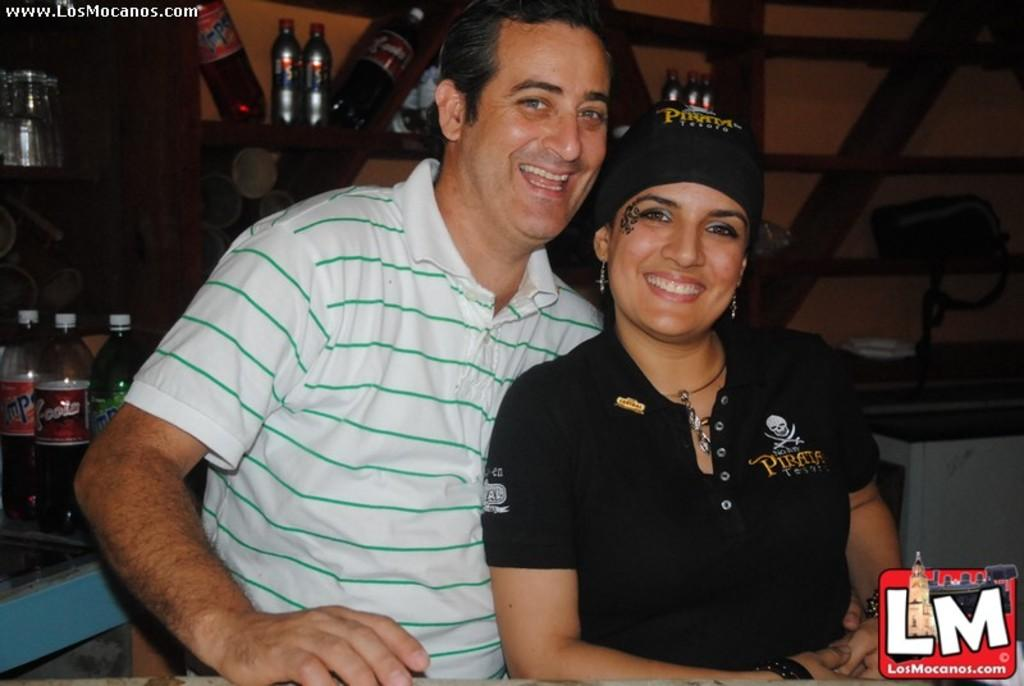Who is present in the image? There is a woman and a man in the image. What are the woman and man doing in the image? The woman and man are sitting and laughing. What can be seen in the background of the image? There are bottles on a wooden rack and a bag in the background. What type of snakes can be seen slithering through the grass in the image? There are no snakes or grass present in the image; it features a woman and a man sitting and laughing. How many birds are perched on the bag in the background? There are no birds present in the image; it only shows a bag in the background. 